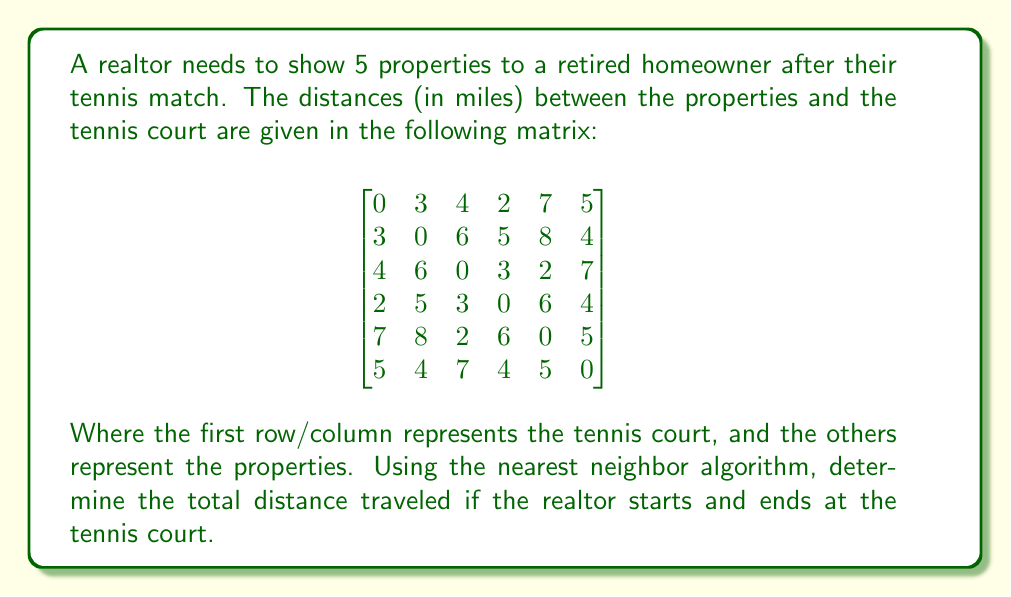Could you help me with this problem? Let's solve this step-by-step using the nearest neighbor algorithm:

1) Start at the tennis court (node 0).

2) Find the nearest unvisited property:
   - Distances from tennis court: 3, 4, 2, 7, 5
   - Nearest is 2 miles away (node 3)

3) Move to node 3. Total distance: 2 miles
   Find the nearest unvisited property:
   - Distances from node 3: 5, 3, 6, 4
   - Nearest is 3 miles away (node 2)

4) Move to node 2. Total distance: 2 + 3 = 5 miles
   Find the nearest unvisited property:
   - Distances from node 2: 6, 2, 7
   - Nearest is 2 miles away (node 4)

5) Move to node 4. Total distance: 5 + 2 = 7 miles
   Find the nearest unvisited property:
   - Distances from node 4: 8, 5
   - Nearest is 5 miles away (node 5)

6) Move to node 5. Total distance: 7 + 5 = 12 miles
   Only one property left to visit (node 1)

7) Move to node 1. Total distance: 12 + 4 = 16 miles

8) Return to the tennis court (node 0). Total distance: 16 + 3 = 19 miles

Therefore, the total distance traveled is 19 miles.
Answer: 19 miles 